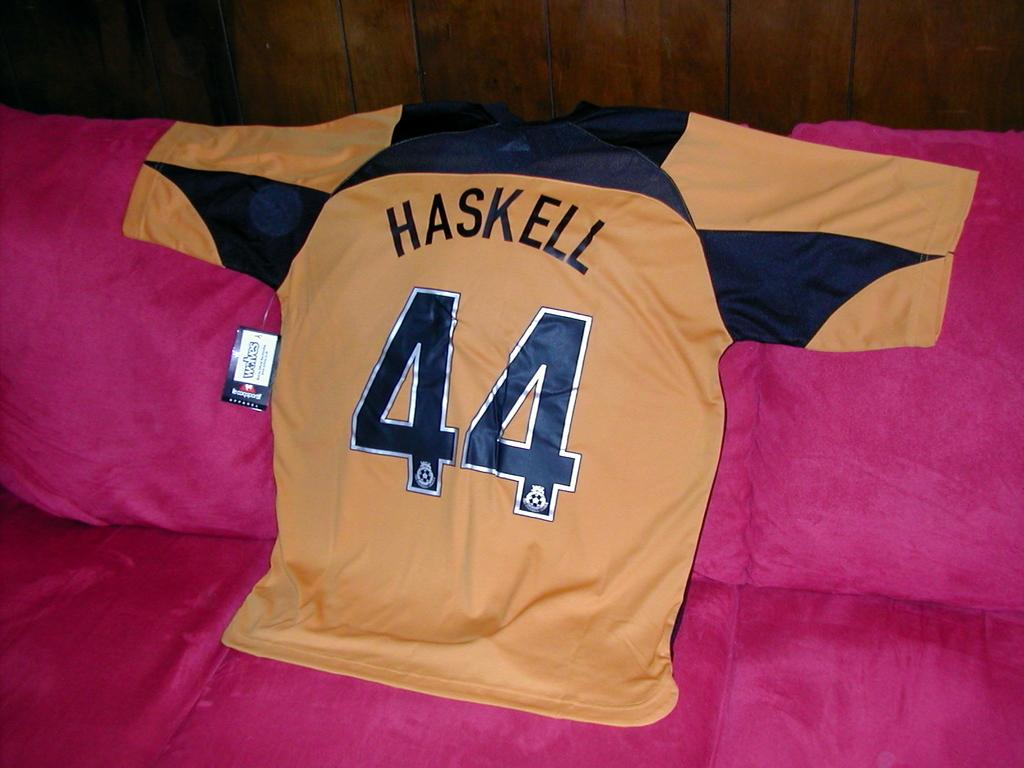<image>
Render a clear and concise summary of the photo. A jersey showing the name Haskell and numbe 44 